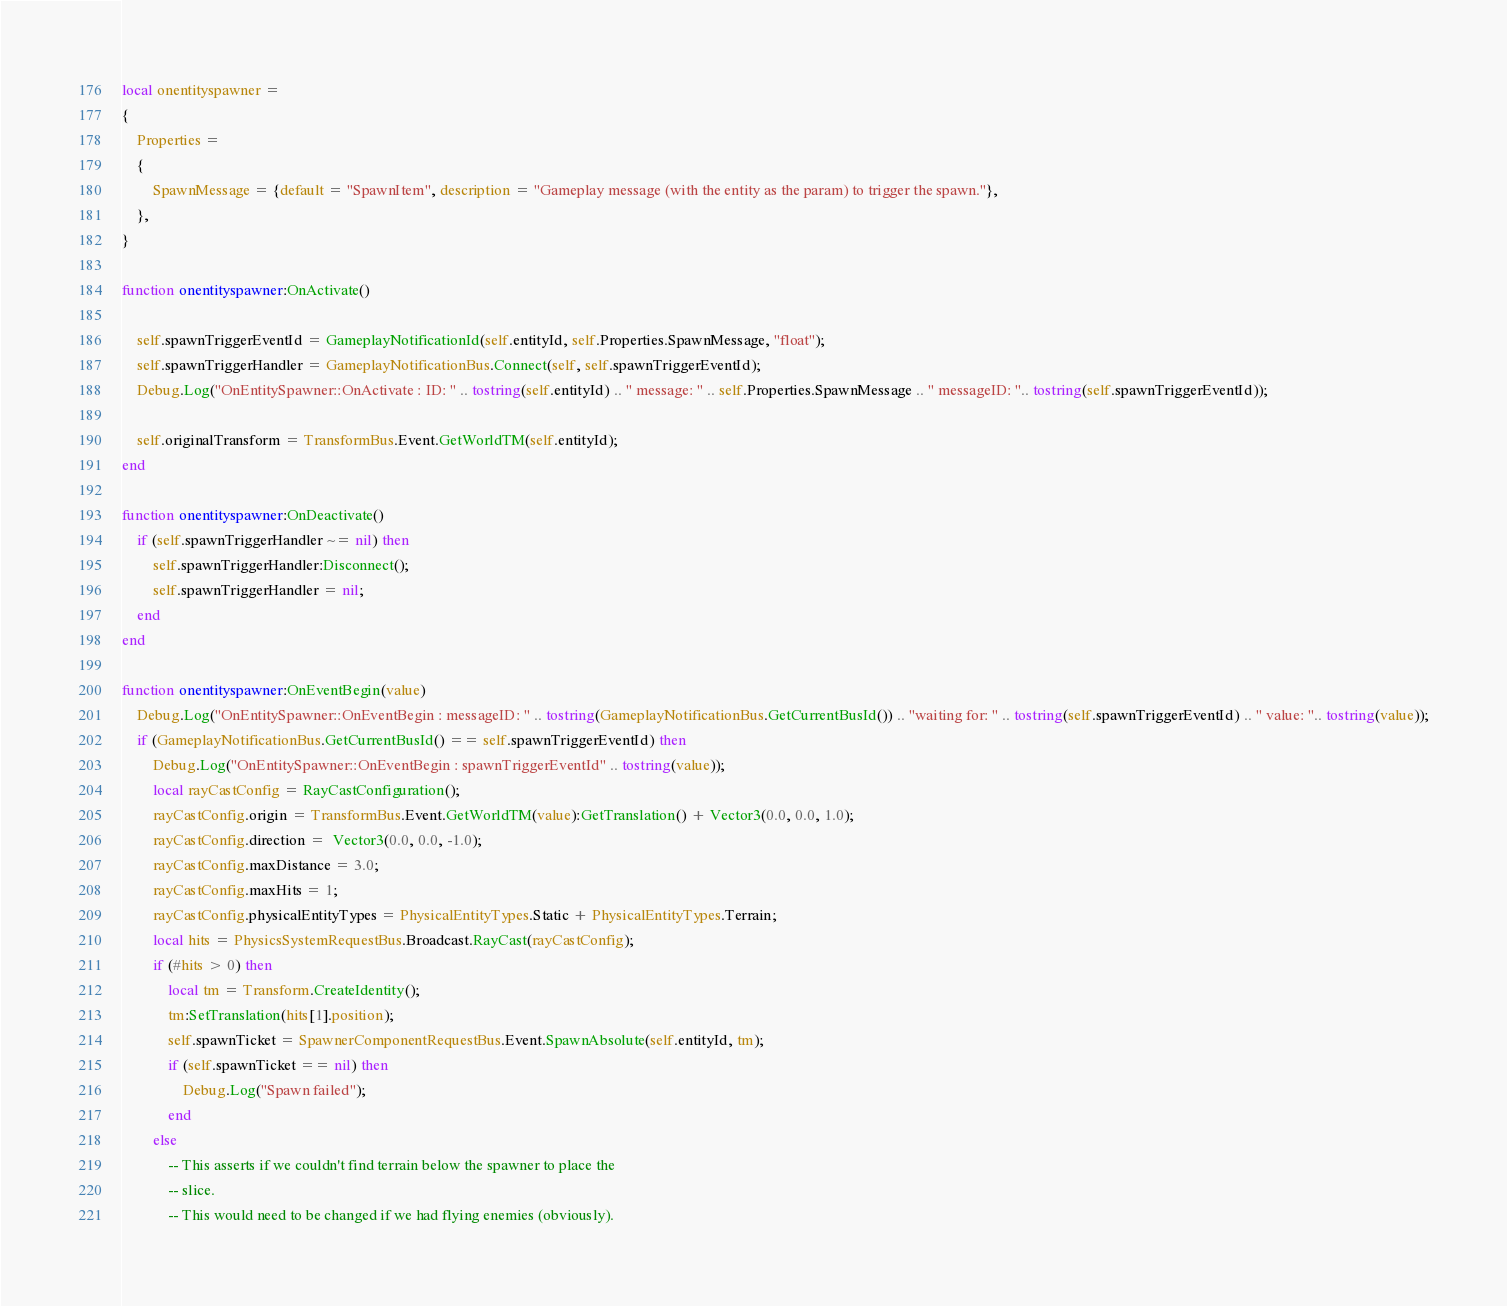<code> <loc_0><loc_0><loc_500><loc_500><_Lua_>local onentityspawner =
{
	Properties =
	{
		SpawnMessage = {default = "SpawnItem", description = "Gameplay message (with the entity as the param) to trigger the spawn."},
	},
}

function onentityspawner:OnActivate()	
	
	self.spawnTriggerEventId = GameplayNotificationId(self.entityId, self.Properties.SpawnMessage, "float");
	self.spawnTriggerHandler = GameplayNotificationBus.Connect(self, self.spawnTriggerEventId);
	Debug.Log("OnEntitySpawner::OnActivate : ID: " .. tostring(self.entityId) .. " message: " .. self.Properties.SpawnMessage .. " messageID: ".. tostring(self.spawnTriggerEventId));

	self.originalTransform = TransformBus.Event.GetWorldTM(self.entityId);	
end

function onentityspawner:OnDeactivate()
	if (self.spawnTriggerHandler ~= nil) then
		self.spawnTriggerHandler:Disconnect();
		self.spawnTriggerHandler = nil;
	end
end

function onentityspawner:OnEventBegin(value)
	Debug.Log("OnEntitySpawner::OnEventBegin : messageID: " .. tostring(GameplayNotificationBus.GetCurrentBusId()) .. "waiting for: " .. tostring(self.spawnTriggerEventId) .. " value: ".. tostring(value));
	if (GameplayNotificationBus.GetCurrentBusId() == self.spawnTriggerEventId) then
		Debug.Log("OnEntitySpawner::OnEventBegin : spawnTriggerEventId" .. tostring(value));
		local rayCastConfig = RayCastConfiguration();
		rayCastConfig.origin = TransformBus.Event.GetWorldTM(value):GetTranslation() + Vector3(0.0, 0.0, 1.0);
		rayCastConfig.direction =  Vector3(0.0, 0.0, -1.0);
		rayCastConfig.maxDistance = 3.0;
		rayCastConfig.maxHits = 1;
		rayCastConfig.physicalEntityTypes = PhysicalEntityTypes.Static + PhysicalEntityTypes.Terrain;		
		local hits = PhysicsSystemRequestBus.Broadcast.RayCast(rayCastConfig);
		if (#hits > 0) then
			local tm = Transform.CreateIdentity();
			tm:SetTranslation(hits[1].position);
			self.spawnTicket = SpawnerComponentRequestBus.Event.SpawnAbsolute(self.entityId, tm);
			if (self.spawnTicket == nil) then
				Debug.Log("Spawn failed");
			end
		else
			-- This asserts if we couldn't find terrain below the spawner to place the
			-- slice.
			-- This would need to be changed if we had flying enemies (obviously).</code> 